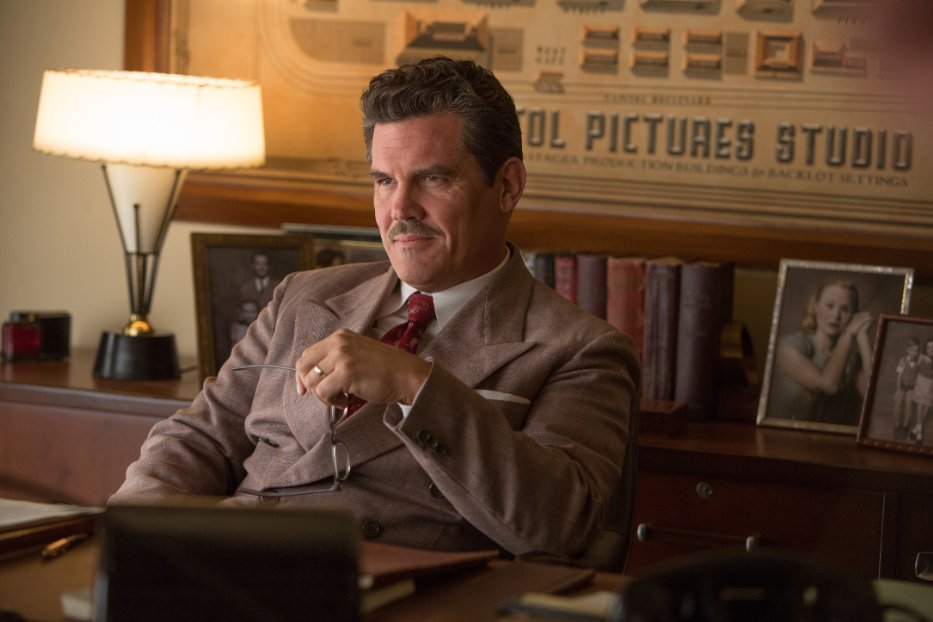If Eddie Mannix could speak, what would he say right now in this scene? 'This is a tough call. The studio's future depends on this decision. I must weigh every option carefully. No room for mistakes here.' 